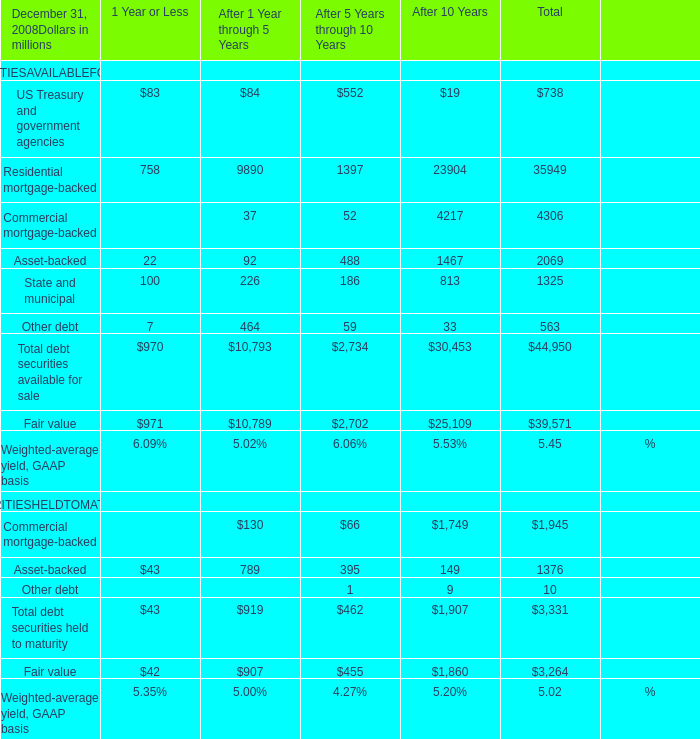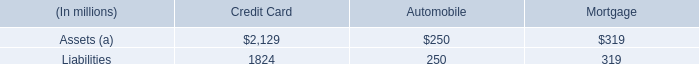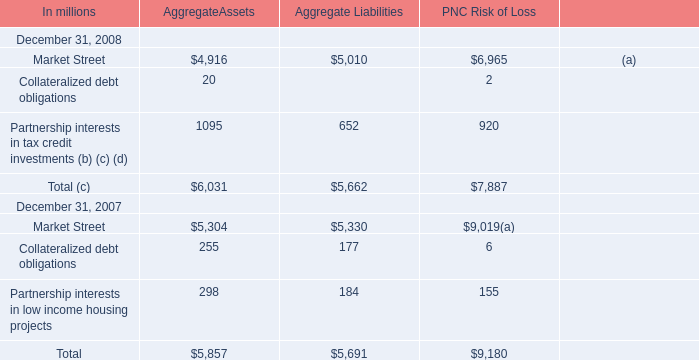What's the average of Fair value of After 10 Years, and Liabilities of Credit Card ? 
Computations: ((25109.0 + 1824.0) / 2)
Answer: 13466.5. 